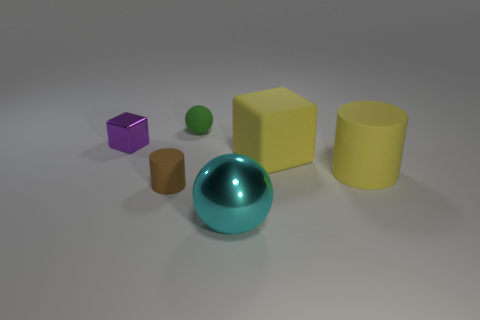Subtract all cyan balls. How many balls are left? 1 Subtract all cylinders. How many objects are left? 4 Add 3 big metallic blocks. How many objects exist? 9 Subtract all green spheres. How many purple cylinders are left? 0 Add 3 large blue rubber cubes. How many large blue rubber cubes exist? 3 Subtract 0 red spheres. How many objects are left? 6 Subtract 2 blocks. How many blocks are left? 0 Subtract all gray balls. Subtract all yellow blocks. How many balls are left? 2 Subtract all metal things. Subtract all big cylinders. How many objects are left? 3 Add 5 cylinders. How many cylinders are left? 7 